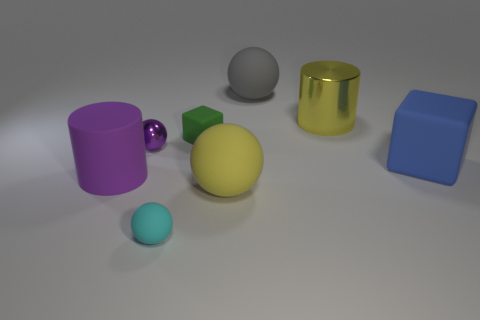How many other objects are the same shape as the large purple thing?
Make the answer very short. 1. Is the number of large yellow rubber spheres that are behind the gray sphere greater than the number of tiny green blocks?
Offer a terse response. No. There is a large object behind the big yellow metal thing; what is its color?
Your answer should be very brief. Gray. What size is the rubber thing that is the same color as the large metallic thing?
Your answer should be very brief. Large. How many matte things are either purple spheres or big blue balls?
Offer a terse response. 0. Is there a purple rubber cylinder that is behind the large rubber object right of the rubber sphere that is behind the metallic cylinder?
Your answer should be very brief. No. What number of purple metal spheres are in front of the yellow cylinder?
Offer a terse response. 1. What is the material of the big cylinder that is the same color as the shiny sphere?
Your response must be concise. Rubber. What number of small things are yellow balls or yellow things?
Your answer should be compact. 0. What is the shape of the large rubber object that is to the right of the big yellow cylinder?
Provide a short and direct response. Cube. 